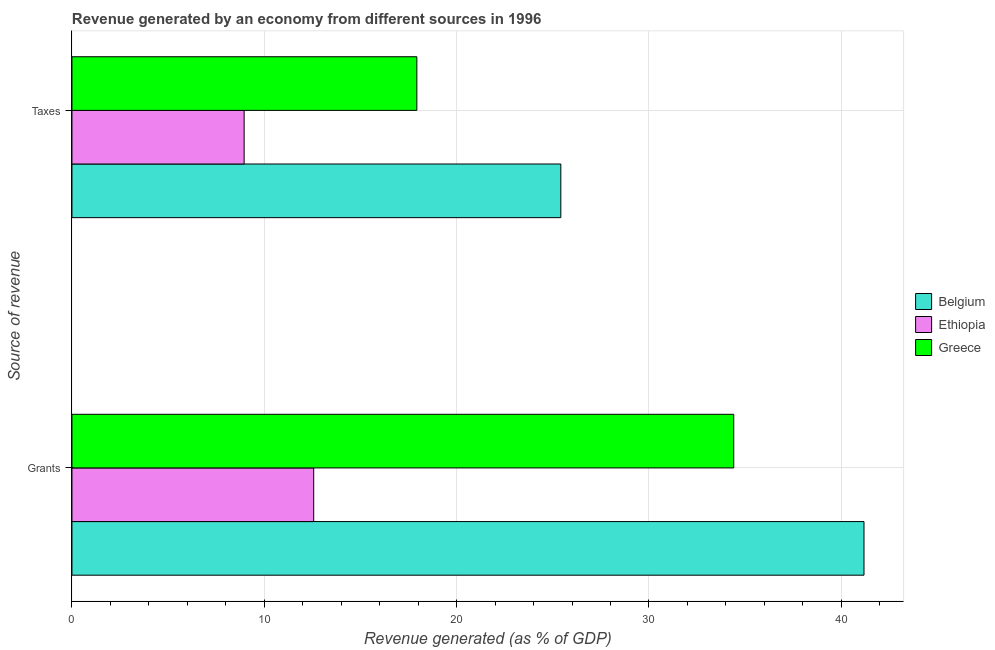How many different coloured bars are there?
Make the answer very short. 3. Are the number of bars per tick equal to the number of legend labels?
Keep it short and to the point. Yes. What is the label of the 2nd group of bars from the top?
Your answer should be compact. Grants. What is the revenue generated by taxes in Belgium?
Make the answer very short. 25.42. Across all countries, what is the maximum revenue generated by taxes?
Provide a succinct answer. 25.42. Across all countries, what is the minimum revenue generated by taxes?
Your response must be concise. 8.95. In which country was the revenue generated by taxes minimum?
Ensure brevity in your answer.  Ethiopia. What is the total revenue generated by taxes in the graph?
Your answer should be very brief. 52.3. What is the difference between the revenue generated by grants in Ethiopia and that in Belgium?
Offer a terse response. -28.61. What is the difference between the revenue generated by taxes in Ethiopia and the revenue generated by grants in Belgium?
Provide a succinct answer. -32.23. What is the average revenue generated by grants per country?
Provide a short and direct response. 29.38. What is the difference between the revenue generated by taxes and revenue generated by grants in Belgium?
Give a very brief answer. -15.76. In how many countries, is the revenue generated by taxes greater than 24 %?
Give a very brief answer. 1. What is the ratio of the revenue generated by taxes in Ethiopia to that in Greece?
Give a very brief answer. 0.5. Is the revenue generated by taxes in Ethiopia less than that in Belgium?
Make the answer very short. Yes. In how many countries, is the revenue generated by taxes greater than the average revenue generated by taxes taken over all countries?
Your answer should be very brief. 2. What does the 3rd bar from the top in Grants represents?
Offer a terse response. Belgium. What does the 3rd bar from the bottom in Taxes represents?
Give a very brief answer. Greece. How many bars are there?
Offer a terse response. 6. Are all the bars in the graph horizontal?
Provide a short and direct response. Yes. Does the graph contain any zero values?
Your answer should be compact. No. Where does the legend appear in the graph?
Keep it short and to the point. Center right. How many legend labels are there?
Offer a terse response. 3. What is the title of the graph?
Make the answer very short. Revenue generated by an economy from different sources in 1996. Does "Vanuatu" appear as one of the legend labels in the graph?
Offer a very short reply. No. What is the label or title of the X-axis?
Provide a short and direct response. Revenue generated (as % of GDP). What is the label or title of the Y-axis?
Provide a short and direct response. Source of revenue. What is the Revenue generated (as % of GDP) of Belgium in Grants?
Your response must be concise. 41.18. What is the Revenue generated (as % of GDP) in Ethiopia in Grants?
Your answer should be compact. 12.57. What is the Revenue generated (as % of GDP) of Greece in Grants?
Offer a terse response. 34.41. What is the Revenue generated (as % of GDP) of Belgium in Taxes?
Your answer should be compact. 25.42. What is the Revenue generated (as % of GDP) in Ethiopia in Taxes?
Your response must be concise. 8.95. What is the Revenue generated (as % of GDP) of Greece in Taxes?
Provide a short and direct response. 17.93. Across all Source of revenue, what is the maximum Revenue generated (as % of GDP) in Belgium?
Offer a terse response. 41.18. Across all Source of revenue, what is the maximum Revenue generated (as % of GDP) of Ethiopia?
Offer a very short reply. 12.57. Across all Source of revenue, what is the maximum Revenue generated (as % of GDP) of Greece?
Provide a short and direct response. 34.41. Across all Source of revenue, what is the minimum Revenue generated (as % of GDP) in Belgium?
Your answer should be very brief. 25.42. Across all Source of revenue, what is the minimum Revenue generated (as % of GDP) of Ethiopia?
Offer a very short reply. 8.95. Across all Source of revenue, what is the minimum Revenue generated (as % of GDP) of Greece?
Your answer should be very brief. 17.93. What is the total Revenue generated (as % of GDP) in Belgium in the graph?
Offer a terse response. 66.6. What is the total Revenue generated (as % of GDP) in Ethiopia in the graph?
Ensure brevity in your answer.  21.52. What is the total Revenue generated (as % of GDP) of Greece in the graph?
Your response must be concise. 52.34. What is the difference between the Revenue generated (as % of GDP) in Belgium in Grants and that in Taxes?
Ensure brevity in your answer.  15.76. What is the difference between the Revenue generated (as % of GDP) in Ethiopia in Grants and that in Taxes?
Provide a succinct answer. 3.62. What is the difference between the Revenue generated (as % of GDP) in Greece in Grants and that in Taxes?
Give a very brief answer. 16.47. What is the difference between the Revenue generated (as % of GDP) of Belgium in Grants and the Revenue generated (as % of GDP) of Ethiopia in Taxes?
Give a very brief answer. 32.23. What is the difference between the Revenue generated (as % of GDP) of Belgium in Grants and the Revenue generated (as % of GDP) of Greece in Taxes?
Provide a short and direct response. 23.25. What is the difference between the Revenue generated (as % of GDP) in Ethiopia in Grants and the Revenue generated (as % of GDP) in Greece in Taxes?
Provide a short and direct response. -5.36. What is the average Revenue generated (as % of GDP) of Belgium per Source of revenue?
Offer a very short reply. 33.3. What is the average Revenue generated (as % of GDP) in Ethiopia per Source of revenue?
Offer a terse response. 10.76. What is the average Revenue generated (as % of GDP) of Greece per Source of revenue?
Make the answer very short. 26.17. What is the difference between the Revenue generated (as % of GDP) of Belgium and Revenue generated (as % of GDP) of Ethiopia in Grants?
Offer a very short reply. 28.61. What is the difference between the Revenue generated (as % of GDP) of Belgium and Revenue generated (as % of GDP) of Greece in Grants?
Provide a short and direct response. 6.77. What is the difference between the Revenue generated (as % of GDP) of Ethiopia and Revenue generated (as % of GDP) of Greece in Grants?
Make the answer very short. -21.84. What is the difference between the Revenue generated (as % of GDP) of Belgium and Revenue generated (as % of GDP) of Ethiopia in Taxes?
Provide a succinct answer. 16.46. What is the difference between the Revenue generated (as % of GDP) of Belgium and Revenue generated (as % of GDP) of Greece in Taxes?
Give a very brief answer. 7.49. What is the difference between the Revenue generated (as % of GDP) of Ethiopia and Revenue generated (as % of GDP) of Greece in Taxes?
Give a very brief answer. -8.98. What is the ratio of the Revenue generated (as % of GDP) of Belgium in Grants to that in Taxes?
Ensure brevity in your answer.  1.62. What is the ratio of the Revenue generated (as % of GDP) of Ethiopia in Grants to that in Taxes?
Your answer should be very brief. 1.4. What is the ratio of the Revenue generated (as % of GDP) in Greece in Grants to that in Taxes?
Provide a succinct answer. 1.92. What is the difference between the highest and the second highest Revenue generated (as % of GDP) of Belgium?
Provide a succinct answer. 15.76. What is the difference between the highest and the second highest Revenue generated (as % of GDP) of Ethiopia?
Your answer should be compact. 3.62. What is the difference between the highest and the second highest Revenue generated (as % of GDP) in Greece?
Give a very brief answer. 16.47. What is the difference between the highest and the lowest Revenue generated (as % of GDP) in Belgium?
Provide a succinct answer. 15.76. What is the difference between the highest and the lowest Revenue generated (as % of GDP) in Ethiopia?
Offer a very short reply. 3.62. What is the difference between the highest and the lowest Revenue generated (as % of GDP) in Greece?
Make the answer very short. 16.47. 